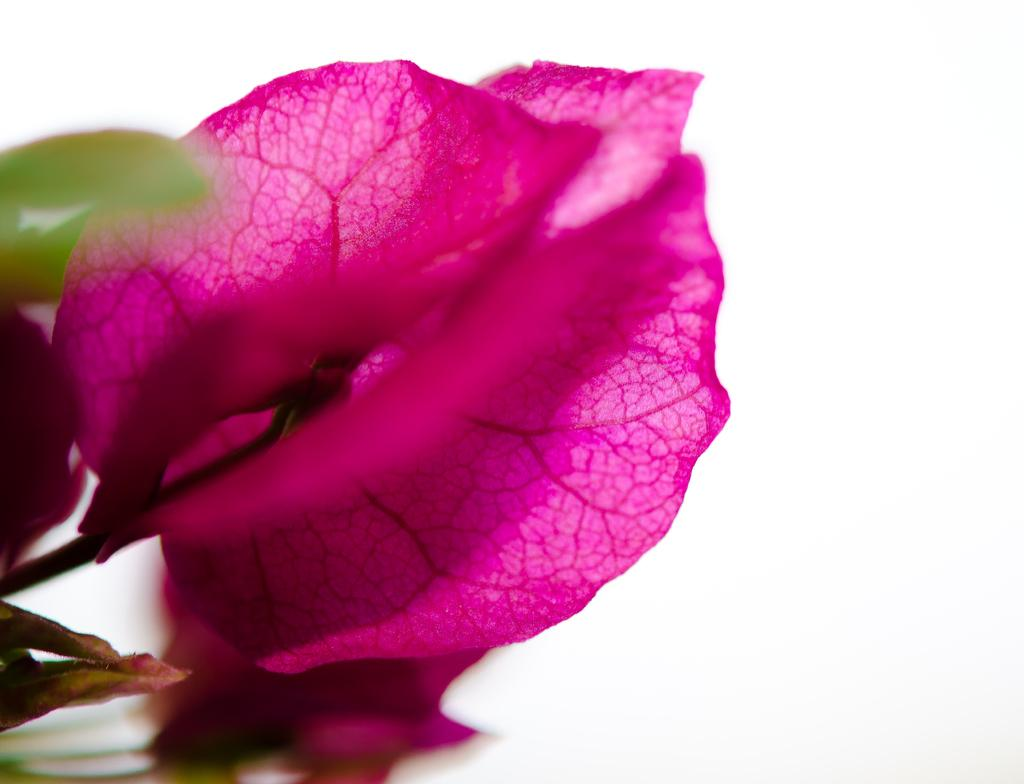What is the main subject of the image? There is a flower in the image. Can you describe the color of the flower? The flower is pink in color. What part of the flower is connected to the stem? There is a stem associated with the flower. What color is the background of the image? The background of the image appears to be white. How many chairs can be seen in the image? There are no chairs present in the image; it features a pink flower with a stem and a white background. Is there a hill visible in the image? There is no hill present in the image; it features a pink flower with a stem and a white background. 